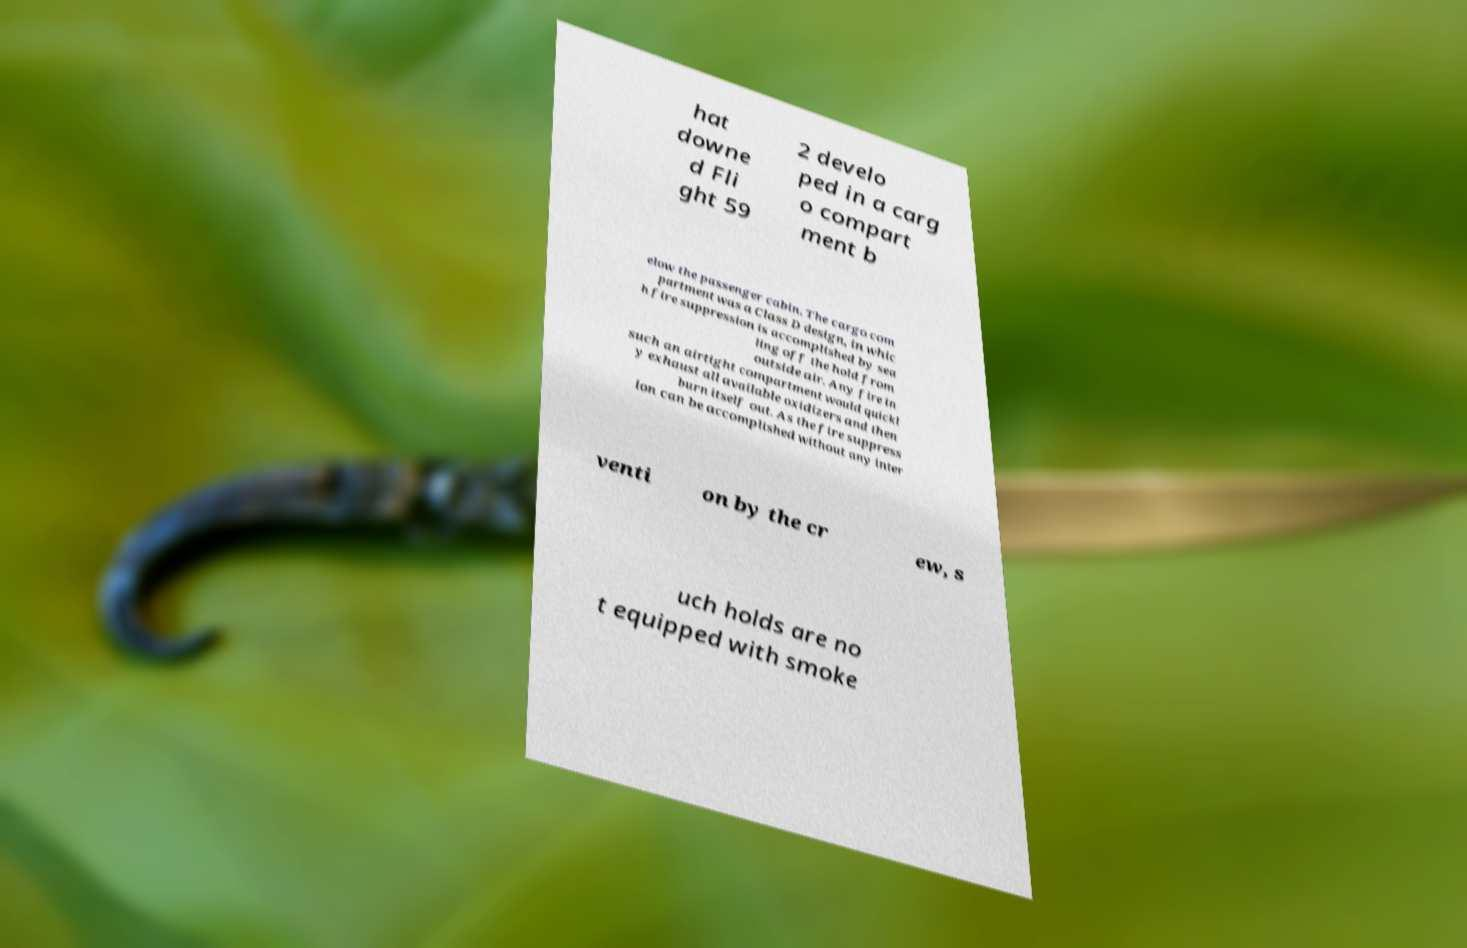Could you extract and type out the text from this image? hat downe d Fli ght 59 2 develo ped in a carg o compart ment b elow the passenger cabin. The cargo com partment was a Class D design, in whic h fire suppression is accomplished by sea ling off the hold from outside air. Any fire in such an airtight compartment would quickl y exhaust all available oxidizers and then burn itself out. As the fire suppress ion can be accomplished without any inter venti on by the cr ew, s uch holds are no t equipped with smoke 